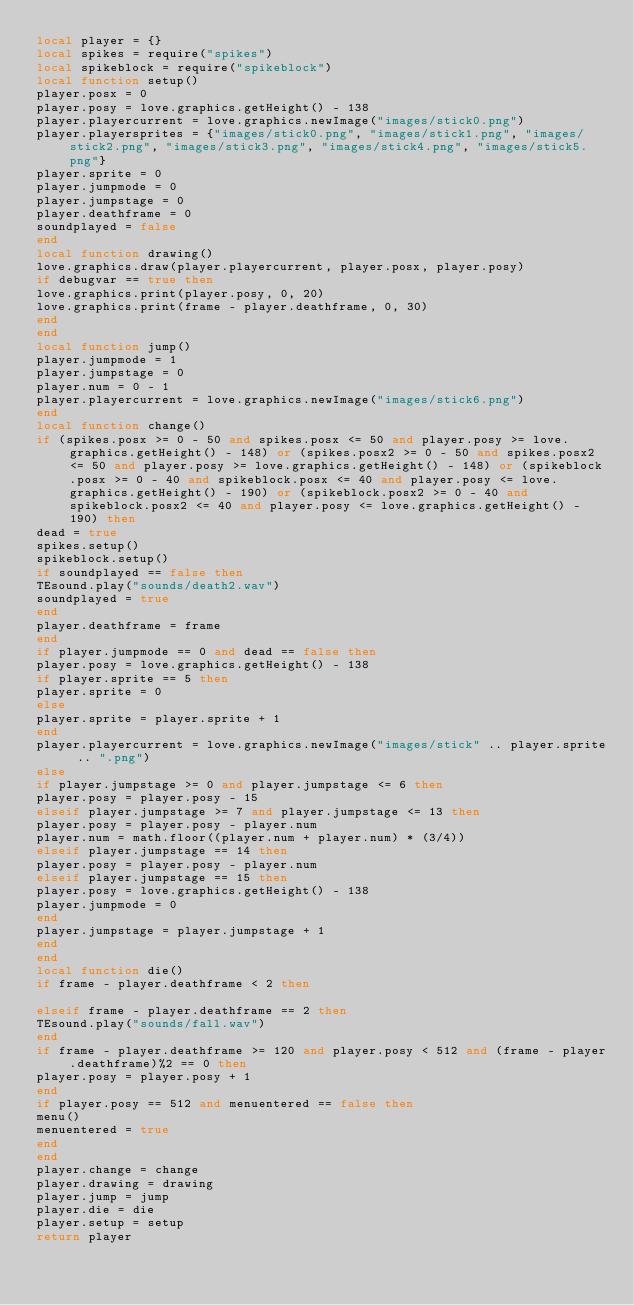<code> <loc_0><loc_0><loc_500><loc_500><_Lua_>local player = {}
local spikes = require("spikes")
local spikeblock = require("spikeblock")
local function setup()
player.posx = 0
player.posy = love.graphics.getHeight() - 138
player.playercurrent = love.graphics.newImage("images/stick0.png")
player.playersprites = {"images/stick0.png", "images/stick1.png", "images/stick2.png", "images/stick3.png", "images/stick4.png", "images/stick5.png"}
player.sprite = 0
player.jumpmode = 0
player.jumpstage = 0
player.deathframe = 0
soundplayed = false
end
local function drawing()
love.graphics.draw(player.playercurrent, player.posx, player.posy)
if debugvar == true then
love.graphics.print(player.posy, 0, 20)
love.graphics.print(frame - player.deathframe, 0, 30)
end
end
local function jump()
player.jumpmode = 1
player.jumpstage = 0
player.num = 0 - 1
player.playercurrent = love.graphics.newImage("images/stick6.png")
end
local function change()
if (spikes.posx >= 0 - 50 and spikes.posx <= 50 and player.posy >= love.graphics.getHeight() - 148) or (spikes.posx2 >= 0 - 50 and spikes.posx2 <= 50 and player.posy >= love.graphics.getHeight() - 148) or (spikeblock.posx >= 0 - 40 and spikeblock.posx <= 40 and player.posy <= love.graphics.getHeight() - 190) or (spikeblock.posx2 >= 0 - 40 and spikeblock.posx2 <= 40 and player.posy <= love.graphics.getHeight() - 190) then
dead = true
spikes.setup()
spikeblock.setup()
if soundplayed == false then
TEsound.play("sounds/death2.wav")
soundplayed = true
end
player.deathframe = frame
end
if player.jumpmode == 0 and dead == false then
player.posy = love.graphics.getHeight() - 138
if player.sprite == 5 then
player.sprite = 0
else
player.sprite = player.sprite + 1
end
player.playercurrent = love.graphics.newImage("images/stick" .. player.sprite .. ".png")
else
if player.jumpstage >= 0 and player.jumpstage <= 6 then
player.posy = player.posy - 15
elseif player.jumpstage >= 7 and player.jumpstage <= 13 then
player.posy = player.posy - player.num
player.num = math.floor((player.num + player.num) * (3/4))
elseif player.jumpstage == 14 then
player.posy = player.posy - player.num
elseif player.jumpstage == 15 then
player.posy = love.graphics.getHeight() - 138
player.jumpmode = 0
end
player.jumpstage = player.jumpstage + 1
end
end
local function die()
if frame - player.deathframe < 2 then

elseif frame - player.deathframe == 2 then
TEsound.play("sounds/fall.wav")
end
if frame - player.deathframe >= 120 and player.posy < 512 and (frame - player.deathframe)%2 == 0 then
player.posy = player.posy + 1
end
if player.posy == 512 and menuentered == false then
menu()
menuentered = true
end
end
player.change = change
player.drawing = drawing
player.jump = jump
player.die = die
player.setup = setup
return player</code> 